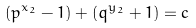Convert formula to latex. <formula><loc_0><loc_0><loc_500><loc_500>( p ^ { x _ { 2 } } - 1 ) + ( q ^ { y _ { 2 } } + 1 ) = c</formula> 